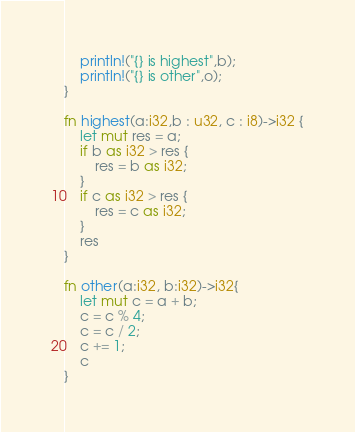<code> <loc_0><loc_0><loc_500><loc_500><_Rust_>    println!("{} is highest",b);
    println!("{} is other",o);
}

fn highest(a:i32,b : u32, c : i8)->i32 {
    let mut res = a;
    if b as i32 > res {
        res = b as i32;
    }
    if c as i32 > res {
        res = c as i32;
    }
    res
}

fn other(a:i32, b:i32)->i32{
    let mut c = a + b;
    c = c % 4;
    c = c / 2;
    c += 1;
    c
}


</code> 